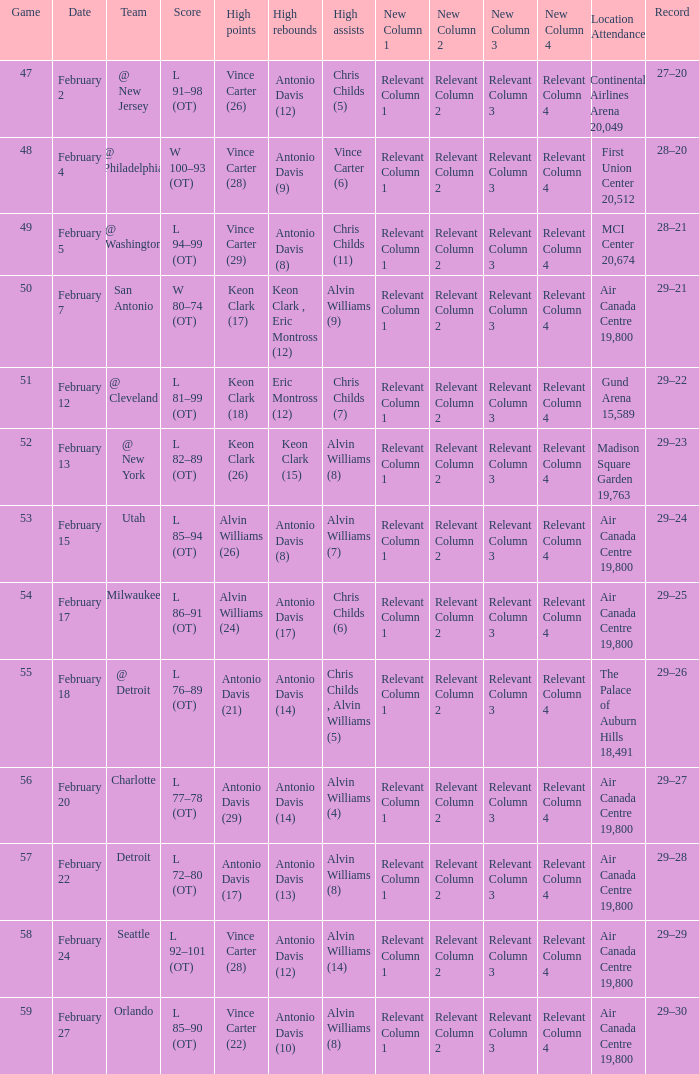Give me the full table as a dictionary. {'header': ['Game', 'Date', 'Team', 'Score', 'High points', 'High rebounds', 'High assists', 'New Column 1', 'New Column 2', 'New Column 3', 'New Column 4', 'Location Attendance', 'Record'], 'rows': [['47', 'February 2', '@ New Jersey', 'L 91–98 (OT)', 'Vince Carter (26)', 'Antonio Davis (12)', 'Chris Childs (5)', 'Relevant Column 1', 'Relevant Column 2', 'Relevant Column 3', 'Relevant Column 4', 'Continental Airlines Arena 20,049', '27–20'], ['48', 'February 4', '@ Philadelphia', 'W 100–93 (OT)', 'Vince Carter (28)', 'Antonio Davis (9)', 'Vince Carter (6)', 'Relevant Column 1', 'Relevant Column 2', 'Relevant Column 3', 'Relevant Column 4', 'First Union Center 20,512', '28–20'], ['49', 'February 5', '@ Washington', 'L 94–99 (OT)', 'Vince Carter (29)', 'Antonio Davis (8)', 'Chris Childs (11)', 'Relevant Column 1', 'Relevant Column 2', 'Relevant Column 3', 'Relevant Column 4', 'MCI Center 20,674', '28–21'], ['50', 'February 7', 'San Antonio', 'W 80–74 (OT)', 'Keon Clark (17)', 'Keon Clark , Eric Montross (12)', 'Alvin Williams (9)', 'Relevant Column 1', 'Relevant Column 2', 'Relevant Column 3', 'Relevant Column 4', 'Air Canada Centre 19,800', '29–21'], ['51', 'February 12', '@ Cleveland', 'L 81–99 (OT)', 'Keon Clark (18)', 'Eric Montross (12)', 'Chris Childs (7)', 'Relevant Column 1', 'Relevant Column 2', 'Relevant Column 3', 'Relevant Column 4', 'Gund Arena 15,589', '29–22'], ['52', 'February 13', '@ New York', 'L 82–89 (OT)', 'Keon Clark (26)', 'Keon Clark (15)', 'Alvin Williams (8)', 'Relevant Column 1', 'Relevant Column 2', 'Relevant Column 3', 'Relevant Column 4', 'Madison Square Garden 19,763', '29–23'], ['53', 'February 15', 'Utah', 'L 85–94 (OT)', 'Alvin Williams (26)', 'Antonio Davis (8)', 'Alvin Williams (7)', 'Relevant Column 1', 'Relevant Column 2', 'Relevant Column 3', 'Relevant Column 4', 'Air Canada Centre 19,800', '29–24'], ['54', 'February 17', 'Milwaukee', 'L 86–91 (OT)', 'Alvin Williams (24)', 'Antonio Davis (17)', 'Chris Childs (6)', 'Relevant Column 1', 'Relevant Column 2', 'Relevant Column 3', 'Relevant Column 4', 'Air Canada Centre 19,800', '29–25'], ['55', 'February 18', '@ Detroit', 'L 76–89 (OT)', 'Antonio Davis (21)', 'Antonio Davis (14)', 'Chris Childs , Alvin Williams (5)', 'Relevant Column 1', 'Relevant Column 2', 'Relevant Column 3', 'Relevant Column 4', 'The Palace of Auburn Hills 18,491', '29–26'], ['56', 'February 20', 'Charlotte', 'L 77–78 (OT)', 'Antonio Davis (29)', 'Antonio Davis (14)', 'Alvin Williams (4)', 'Relevant Column 1', 'Relevant Column 2', 'Relevant Column 3', 'Relevant Column 4', 'Air Canada Centre 19,800', '29–27'], ['57', 'February 22', 'Detroit', 'L 72–80 (OT)', 'Antonio Davis (17)', 'Antonio Davis (13)', 'Alvin Williams (8)', 'Relevant Column 1', 'Relevant Column 2', 'Relevant Column 3', 'Relevant Column 4', 'Air Canada Centre 19,800', '29–28'], ['58', 'February 24', 'Seattle', 'L 92–101 (OT)', 'Vince Carter (28)', 'Antonio Davis (12)', 'Alvin Williams (14)', 'Relevant Column 1', 'Relevant Column 2', 'Relevant Column 3', 'Relevant Column 4', 'Air Canada Centre 19,800', '29–29'], ['59', 'February 27', 'Orlando', 'L 85–90 (OT)', 'Vince Carter (22)', 'Antonio Davis (10)', 'Alvin Williams (8)', 'Relevant Column 1', 'Relevant Column 2', 'Relevant Column 3', 'Relevant Column 4', 'Air Canada Centre 19,800', '29–30']]} What is the Team with a game of more than 56, and the score is l 85–90 (ot)? Orlando. 